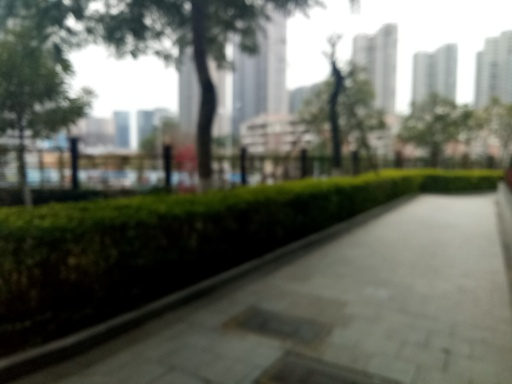Is the overall clarity of the image high?
A. Yes
B. No
Answer with the option's letter from the given choices directly.
 B. 